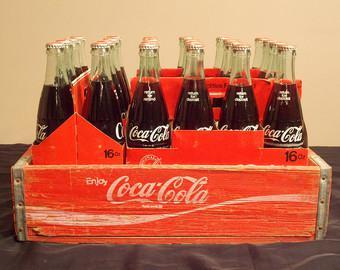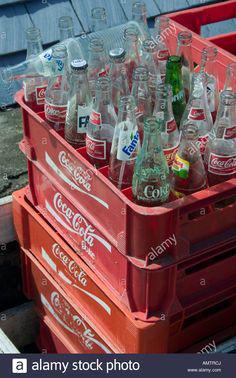The first image is the image on the left, the second image is the image on the right. Considering the images on both sides, is "The left image features filled cola bottles in a red wooden crate with low sides." valid? Answer yes or no. Yes. The first image is the image on the left, the second image is the image on the right. For the images displayed, is the sentence "The bottles in the left image are unopened." factually correct? Answer yes or no. Yes. 